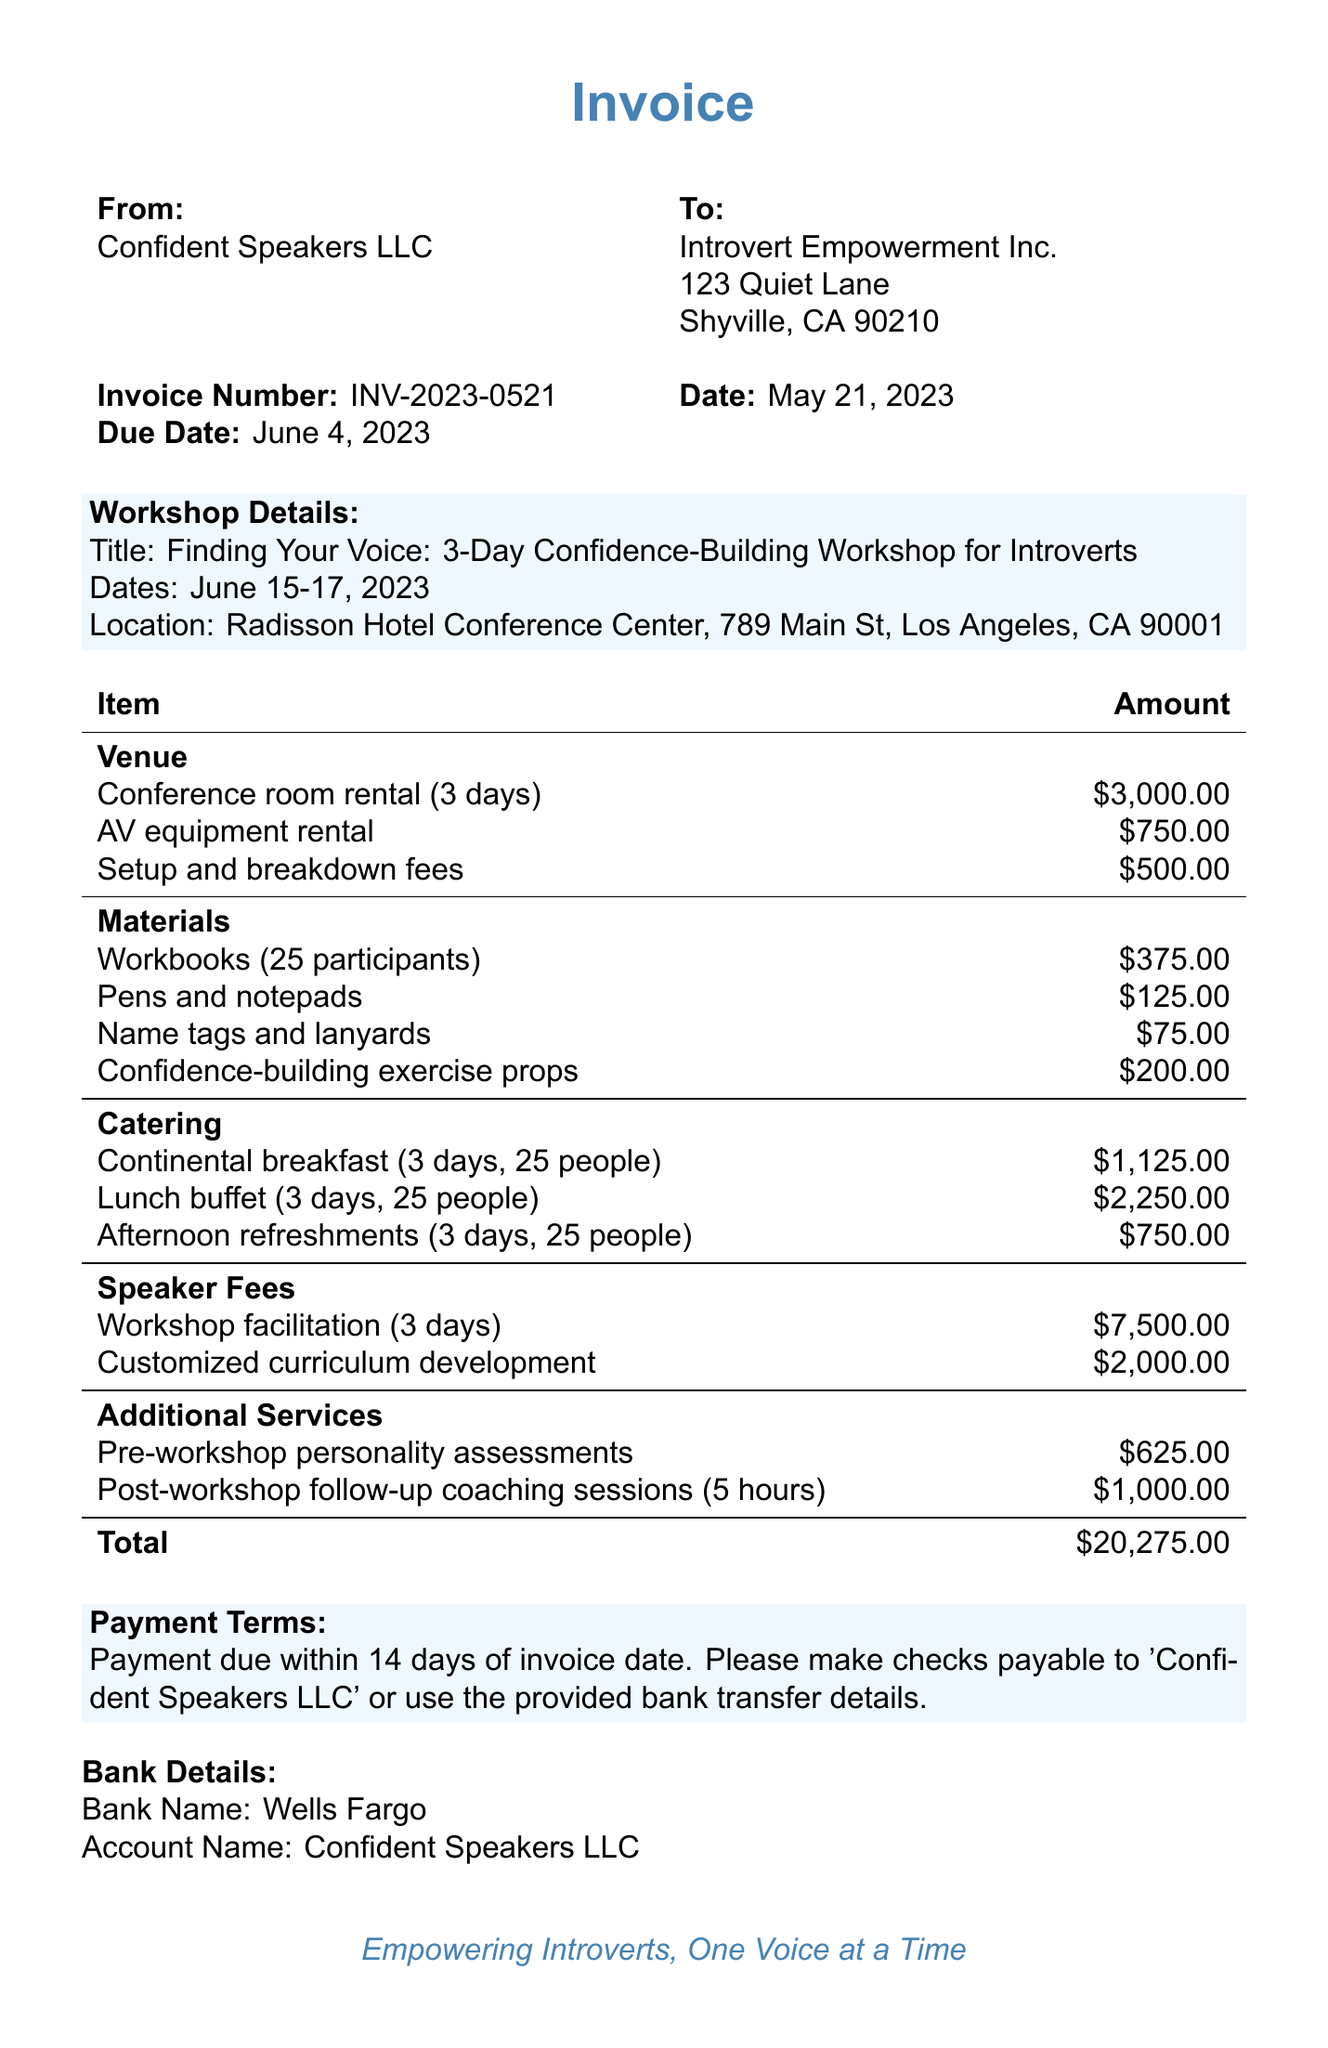What is the invoice number? The invoice number is directly listed in the invoice details as INV-2023-0521.
Answer: INV-2023-0521 What are the workshop dates? The workshop dates are specified under workshop details as June 15-17, 2023.
Answer: June 15-17, 2023 How much is the venue cost? To find the venue cost, we can sum the rental, equipment rental, and setup fees listed in the itemized costs.
Answer: $4,250.00 What is the total cost of the invoice? The total cost is stated at the end of the itemized costs section as $20,275.00.
Answer: $20,275.00 What is the account name for bank transfer? The bank details specify the account name as Confident Speakers LLC.
Answer: Confident Speakers LLC How many participants are included in the workbooks? The itemized cost for workbooks indicates that they are for 25 participants.
Answer: 25 participants What is the payment due date? The due date is found in the invoice details listed as June 4, 2023.
Answer: June 4, 2023 What additional service is provided after the workshop? The document specifies post-workshop follow-up coaching sessions as an additional service.
Answer: Post-workshop follow-up coaching sessions Who is the client for the invoice? The client's name is listed at the top of the document under "To," as Introvert Empowerment Inc.
Answer: Introvert Empowerment Inc 